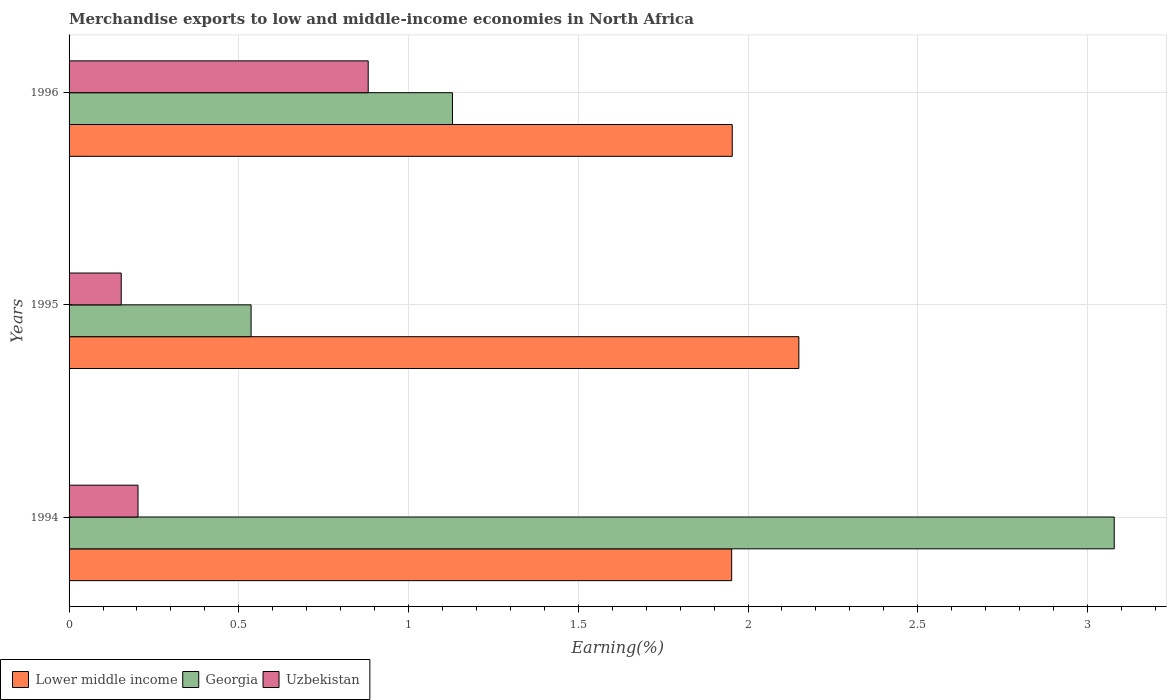How many different coloured bars are there?
Your response must be concise. 3. How many groups of bars are there?
Keep it short and to the point. 3. Are the number of bars per tick equal to the number of legend labels?
Provide a short and direct response. Yes. How many bars are there on the 2nd tick from the top?
Keep it short and to the point. 3. How many bars are there on the 1st tick from the bottom?
Offer a very short reply. 3. What is the label of the 1st group of bars from the top?
Your response must be concise. 1996. In how many cases, is the number of bars for a given year not equal to the number of legend labels?
Give a very brief answer. 0. What is the percentage of amount earned from merchandise exports in Uzbekistan in 1996?
Offer a very short reply. 0.88. Across all years, what is the maximum percentage of amount earned from merchandise exports in Uzbekistan?
Your answer should be compact. 0.88. Across all years, what is the minimum percentage of amount earned from merchandise exports in Uzbekistan?
Provide a succinct answer. 0.15. In which year was the percentage of amount earned from merchandise exports in Georgia minimum?
Provide a short and direct response. 1995. What is the total percentage of amount earned from merchandise exports in Uzbekistan in the graph?
Keep it short and to the point. 1.24. What is the difference between the percentage of amount earned from merchandise exports in Uzbekistan in 1995 and that in 1996?
Give a very brief answer. -0.73. What is the difference between the percentage of amount earned from merchandise exports in Georgia in 1994 and the percentage of amount earned from merchandise exports in Uzbekistan in 1996?
Make the answer very short. 2.2. What is the average percentage of amount earned from merchandise exports in Uzbekistan per year?
Provide a short and direct response. 0.41. In the year 1994, what is the difference between the percentage of amount earned from merchandise exports in Georgia and percentage of amount earned from merchandise exports in Uzbekistan?
Offer a terse response. 2.88. In how many years, is the percentage of amount earned from merchandise exports in Lower middle income greater than 1.4 %?
Your answer should be very brief. 3. What is the ratio of the percentage of amount earned from merchandise exports in Uzbekistan in 1995 to that in 1996?
Make the answer very short. 0.17. What is the difference between the highest and the second highest percentage of amount earned from merchandise exports in Georgia?
Make the answer very short. 1.95. What is the difference between the highest and the lowest percentage of amount earned from merchandise exports in Uzbekistan?
Offer a very short reply. 0.73. Is the sum of the percentage of amount earned from merchandise exports in Uzbekistan in 1994 and 1996 greater than the maximum percentage of amount earned from merchandise exports in Georgia across all years?
Make the answer very short. No. What does the 2nd bar from the top in 1996 represents?
Provide a succinct answer. Georgia. What does the 3rd bar from the bottom in 1995 represents?
Your answer should be compact. Uzbekistan. Is it the case that in every year, the sum of the percentage of amount earned from merchandise exports in Georgia and percentage of amount earned from merchandise exports in Lower middle income is greater than the percentage of amount earned from merchandise exports in Uzbekistan?
Offer a terse response. Yes. How many years are there in the graph?
Give a very brief answer. 3. Does the graph contain any zero values?
Your response must be concise. No. Where does the legend appear in the graph?
Provide a short and direct response. Bottom left. What is the title of the graph?
Give a very brief answer. Merchandise exports to low and middle-income economies in North Africa. What is the label or title of the X-axis?
Provide a succinct answer. Earning(%). What is the Earning(%) of Lower middle income in 1994?
Your answer should be very brief. 1.95. What is the Earning(%) in Georgia in 1994?
Your answer should be very brief. 3.08. What is the Earning(%) of Uzbekistan in 1994?
Offer a very short reply. 0.2. What is the Earning(%) in Lower middle income in 1995?
Provide a succinct answer. 2.15. What is the Earning(%) in Georgia in 1995?
Provide a succinct answer. 0.54. What is the Earning(%) in Uzbekistan in 1995?
Make the answer very short. 0.15. What is the Earning(%) in Lower middle income in 1996?
Offer a very short reply. 1.95. What is the Earning(%) of Georgia in 1996?
Your answer should be very brief. 1.13. What is the Earning(%) in Uzbekistan in 1996?
Provide a succinct answer. 0.88. Across all years, what is the maximum Earning(%) in Lower middle income?
Keep it short and to the point. 2.15. Across all years, what is the maximum Earning(%) in Georgia?
Provide a succinct answer. 3.08. Across all years, what is the maximum Earning(%) of Uzbekistan?
Your response must be concise. 0.88. Across all years, what is the minimum Earning(%) in Lower middle income?
Your answer should be very brief. 1.95. Across all years, what is the minimum Earning(%) of Georgia?
Your response must be concise. 0.54. Across all years, what is the minimum Earning(%) in Uzbekistan?
Keep it short and to the point. 0.15. What is the total Earning(%) in Lower middle income in the graph?
Provide a succinct answer. 6.05. What is the total Earning(%) of Georgia in the graph?
Give a very brief answer. 4.74. What is the total Earning(%) in Uzbekistan in the graph?
Offer a very short reply. 1.24. What is the difference between the Earning(%) of Lower middle income in 1994 and that in 1995?
Your answer should be compact. -0.2. What is the difference between the Earning(%) of Georgia in 1994 and that in 1995?
Your answer should be compact. 2.54. What is the difference between the Earning(%) in Uzbekistan in 1994 and that in 1995?
Give a very brief answer. 0.05. What is the difference between the Earning(%) of Lower middle income in 1994 and that in 1996?
Ensure brevity in your answer.  -0. What is the difference between the Earning(%) of Georgia in 1994 and that in 1996?
Give a very brief answer. 1.95. What is the difference between the Earning(%) in Uzbekistan in 1994 and that in 1996?
Ensure brevity in your answer.  -0.68. What is the difference between the Earning(%) in Lower middle income in 1995 and that in 1996?
Your answer should be very brief. 0.2. What is the difference between the Earning(%) of Georgia in 1995 and that in 1996?
Your answer should be very brief. -0.59. What is the difference between the Earning(%) in Uzbekistan in 1995 and that in 1996?
Ensure brevity in your answer.  -0.73. What is the difference between the Earning(%) of Lower middle income in 1994 and the Earning(%) of Georgia in 1995?
Make the answer very short. 1.42. What is the difference between the Earning(%) in Lower middle income in 1994 and the Earning(%) in Uzbekistan in 1995?
Offer a very short reply. 1.8. What is the difference between the Earning(%) in Georgia in 1994 and the Earning(%) in Uzbekistan in 1995?
Provide a succinct answer. 2.93. What is the difference between the Earning(%) in Lower middle income in 1994 and the Earning(%) in Georgia in 1996?
Give a very brief answer. 0.82. What is the difference between the Earning(%) of Lower middle income in 1994 and the Earning(%) of Uzbekistan in 1996?
Give a very brief answer. 1.07. What is the difference between the Earning(%) in Georgia in 1994 and the Earning(%) in Uzbekistan in 1996?
Offer a very short reply. 2.2. What is the difference between the Earning(%) in Lower middle income in 1995 and the Earning(%) in Georgia in 1996?
Offer a terse response. 1.02. What is the difference between the Earning(%) of Lower middle income in 1995 and the Earning(%) of Uzbekistan in 1996?
Give a very brief answer. 1.27. What is the difference between the Earning(%) in Georgia in 1995 and the Earning(%) in Uzbekistan in 1996?
Your answer should be very brief. -0.34. What is the average Earning(%) of Lower middle income per year?
Ensure brevity in your answer.  2.02. What is the average Earning(%) in Georgia per year?
Your answer should be compact. 1.58. What is the average Earning(%) in Uzbekistan per year?
Give a very brief answer. 0.41. In the year 1994, what is the difference between the Earning(%) of Lower middle income and Earning(%) of Georgia?
Your response must be concise. -1.13. In the year 1994, what is the difference between the Earning(%) in Lower middle income and Earning(%) in Uzbekistan?
Give a very brief answer. 1.75. In the year 1994, what is the difference between the Earning(%) of Georgia and Earning(%) of Uzbekistan?
Your response must be concise. 2.88. In the year 1995, what is the difference between the Earning(%) of Lower middle income and Earning(%) of Georgia?
Provide a succinct answer. 1.61. In the year 1995, what is the difference between the Earning(%) in Lower middle income and Earning(%) in Uzbekistan?
Offer a terse response. 2. In the year 1995, what is the difference between the Earning(%) in Georgia and Earning(%) in Uzbekistan?
Make the answer very short. 0.38. In the year 1996, what is the difference between the Earning(%) in Lower middle income and Earning(%) in Georgia?
Keep it short and to the point. 0.82. In the year 1996, what is the difference between the Earning(%) of Lower middle income and Earning(%) of Uzbekistan?
Give a very brief answer. 1.07. In the year 1996, what is the difference between the Earning(%) in Georgia and Earning(%) in Uzbekistan?
Your response must be concise. 0.25. What is the ratio of the Earning(%) of Lower middle income in 1994 to that in 1995?
Ensure brevity in your answer.  0.91. What is the ratio of the Earning(%) of Georgia in 1994 to that in 1995?
Provide a succinct answer. 5.74. What is the ratio of the Earning(%) of Uzbekistan in 1994 to that in 1995?
Your answer should be very brief. 1.32. What is the ratio of the Earning(%) of Lower middle income in 1994 to that in 1996?
Provide a succinct answer. 1. What is the ratio of the Earning(%) of Georgia in 1994 to that in 1996?
Your answer should be compact. 2.73. What is the ratio of the Earning(%) of Uzbekistan in 1994 to that in 1996?
Offer a terse response. 0.23. What is the ratio of the Earning(%) in Lower middle income in 1995 to that in 1996?
Provide a short and direct response. 1.1. What is the ratio of the Earning(%) in Georgia in 1995 to that in 1996?
Keep it short and to the point. 0.47. What is the ratio of the Earning(%) in Uzbekistan in 1995 to that in 1996?
Keep it short and to the point. 0.17. What is the difference between the highest and the second highest Earning(%) of Lower middle income?
Keep it short and to the point. 0.2. What is the difference between the highest and the second highest Earning(%) in Georgia?
Ensure brevity in your answer.  1.95. What is the difference between the highest and the second highest Earning(%) in Uzbekistan?
Ensure brevity in your answer.  0.68. What is the difference between the highest and the lowest Earning(%) of Lower middle income?
Make the answer very short. 0.2. What is the difference between the highest and the lowest Earning(%) of Georgia?
Provide a short and direct response. 2.54. What is the difference between the highest and the lowest Earning(%) in Uzbekistan?
Offer a very short reply. 0.73. 